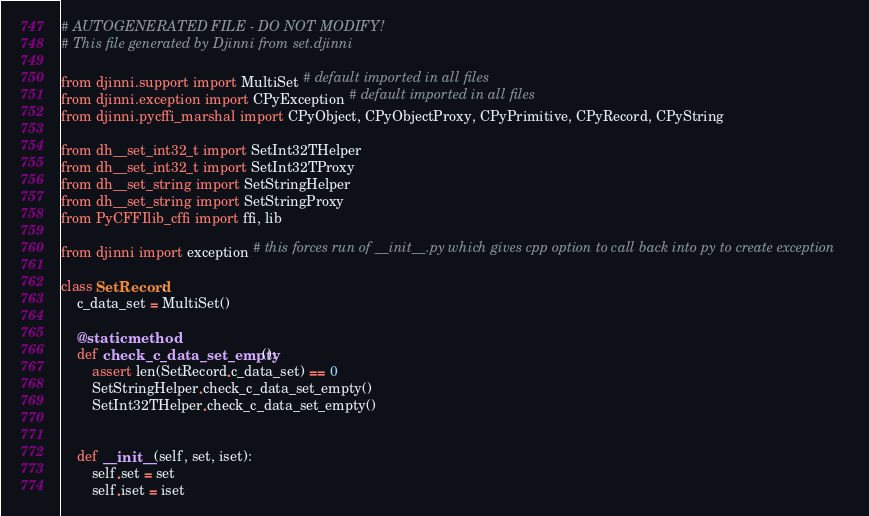<code> <loc_0><loc_0><loc_500><loc_500><_Python_># AUTOGENERATED FILE - DO NOT MODIFY!
# This file generated by Djinni from set.djinni

from djinni.support import MultiSet # default imported in all files
from djinni.exception import CPyException # default imported in all files
from djinni.pycffi_marshal import CPyObject, CPyObjectProxy, CPyPrimitive, CPyRecord, CPyString

from dh__set_int32_t import SetInt32THelper
from dh__set_int32_t import SetInt32TProxy
from dh__set_string import SetStringHelper
from dh__set_string import SetStringProxy
from PyCFFIlib_cffi import ffi, lib

from djinni import exception # this forces run of __init__.py which gives cpp option to call back into py to create exception

class SetRecord:
    c_data_set = MultiSet()

    @staticmethod
    def check_c_data_set_empty():
        assert len(SetRecord.c_data_set) == 0
        SetStringHelper.check_c_data_set_empty()
        SetInt32THelper.check_c_data_set_empty()


    def __init__(self, set, iset):
        self.set = set
        self.iset = iset

</code> 